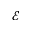<formula> <loc_0><loc_0><loc_500><loc_500>\mathcal { E }</formula> 